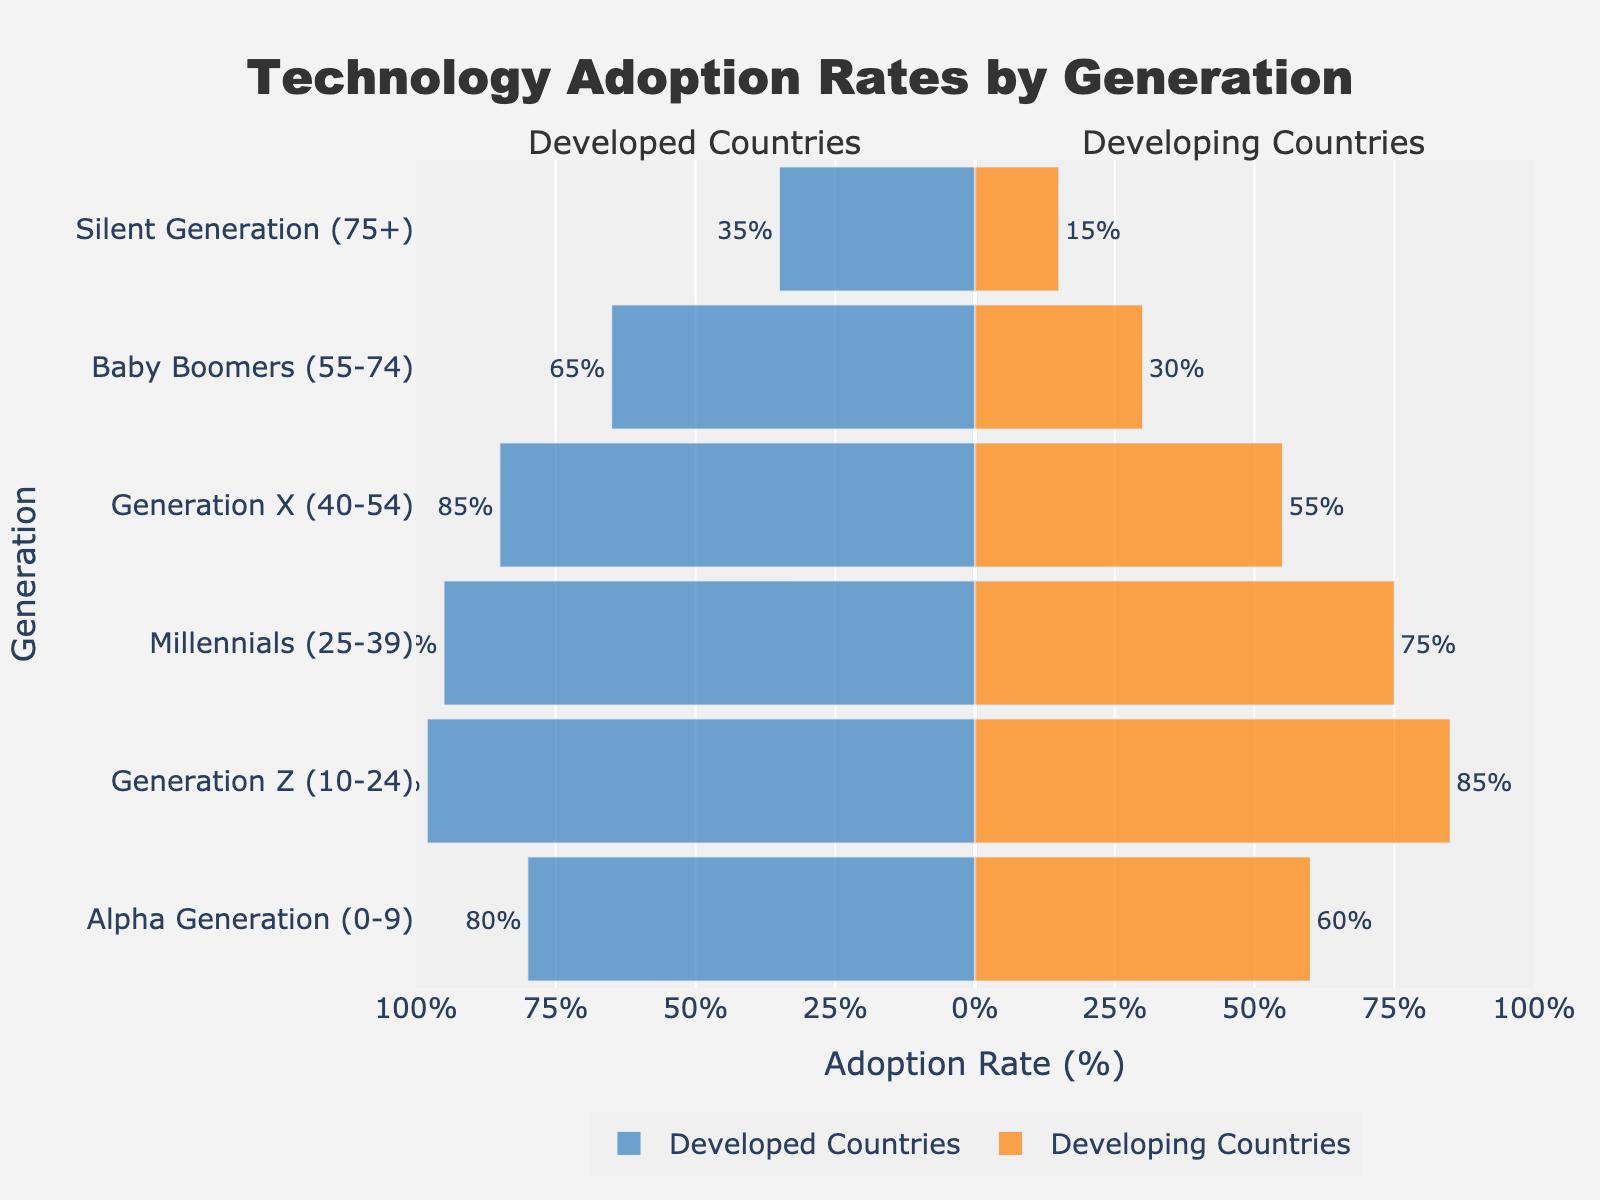What is the adoption rate of Generation Z in developing countries? To find this, look for the bar representing Generation Z and check the label for developing countries. The adoption rate is indicated as a percentage alongside the bar.
Answer: 85% Which country category has a higher technology adoption rate among Baby Boomers? Compare the bars for Baby Boomers between developed and developing countries. The developed countries' bar is longer and shows a higher percentage.
Answer: Developed countries What is the difference in technology adoption rates between Generation X in developed and developing countries? Find the bars for Generation X in both developed and developing categories, note their percentages and calculate the difference (85% - 55% = 30%).
Answer: 30% Which generation has the highest technology adoption rate in developing countries? Identify the generation with the longest bar for developing countries. Generation Z's bar is the longest with 85%.
Answer: Generation Z How does the adoption rate of Generation Alpha in developed countries compare to that in developing countries? Compare the bars for Generation Alpha in both categories by checking their lengths and percentages. Developed countries have 80% while developing countries have 60%.
Answer: Higher in developed countries What is the sum of technology adoption rates for Millennials and Generation Z in developing countries? Find the adoption rates for Millennials (75%) and Generation Z (85%) in developing countries and add them together (75% + 85% = 160%).
Answer: 160% Which generation shows the greatest disparity in technology adoption rates between developed and developing countries? Compare the differences in adoption rates across all generations. Baby Boomers have the greatest disparity (65% - 30% = 35%).
Answer: Baby Boomers What is the average technology adoption rate of the Silent Generation and Baby Boomers in developed countries? Find adoption rates for Silent Generation (35%) and Baby Boomers (65%) and calculate the average ((35% + 65%) / 2 = 50%).
Answer: 50% Which generation shows a decreasing technology adoption trend in developing countries compared to the previous generation? Compare each generation’s rate to the previous one. Alpha Generation (60%) is lower than Generation Z (85%).
Answer: Alpha Generation 